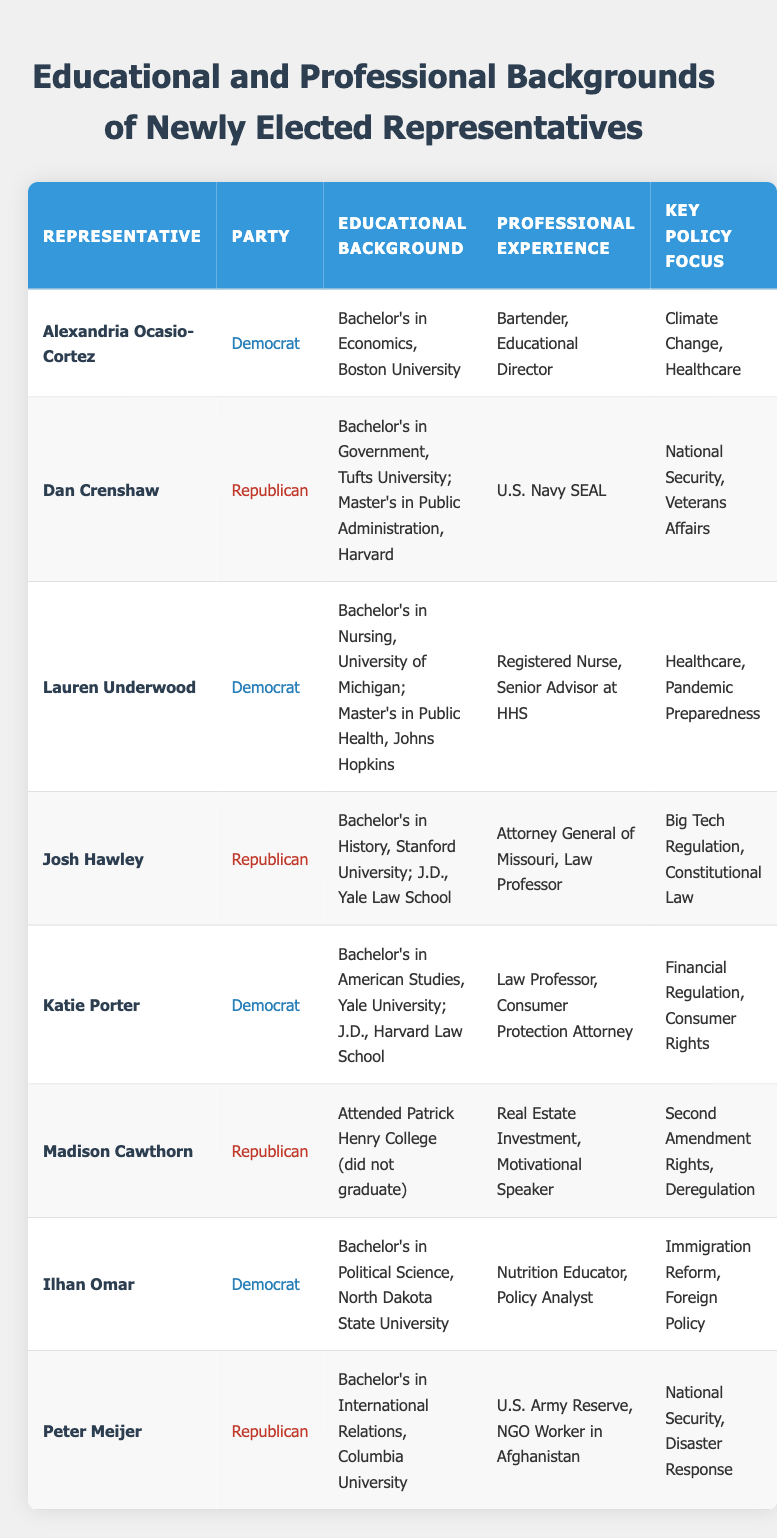What is the educational background of Alexandria Ocasio-Cortez? Alexandria Ocasio-Cortez has a Bachelor's degree in Economics from Boston University, as clearly stated in the "Educational Background" column for her row.
Answer: Bachelor's in Economics, Boston University Which party does Lauren Underwood belong to? In the row for Lauren Underwood, the "Party" column specifies that she is a Democrat.
Answer: Democrat Who has the most extensive educational qualifications? To determine this, we look at the educational background of each representative. Dan Crenshaw has both a Bachelor's in Government and a Master's in Public Administration, whereas others have fewer degrees. Therefore, he has the most extensive qualifications.
Answer: Dan Crenshaw How many representatives have a background in healthcare? We filter the table for representatives whose professional experience or policy focus indicates a healthcare background. Both Alexandria Ocasio-Cortez and Lauren Underwood are directly involved with healthcare. This totals to two representatives with a focus in this area.
Answer: 2 True or False: Madison Cawthorn graduated from Patrick Henry College. The educational background for Madison Cawthorn states that he "Attended Patrick Henry College (did not graduate)," which clearly indicates that he did not complete his degree.
Answer: False What is the average number of educational degrees held by the representatives listed? Counting the degrees: Ocasio-Cortez (1), Crenshaw (2), Underwood (2), Hawley (2), Porter (2), Cawthorn (0), Omar (1), Meijer (1) gives a total of 11 degrees. Since there are 8 representatives, the average is calculated as 11/8 = 1.375 degrees.
Answer: 1.375 Which representative's professional experience includes military service? Peter Meijer is noted to have served in the U.S. Army Reserve, as indicated in the "Professional Experience" column for his row.
Answer: Peter Meijer Which key policy focus is unique to Josh Hawley? Upon examining the key policy focus column, "Big Tech Regulation" is uniquely stated for Josh Hawley, while it is not mentioned for any other representatives.
Answer: Big Tech Regulation How many representatives attended Ivy League schools? The table mentions that Josh Hawley (Yale), Katie Porter (Harvard), and Dan Crenshaw (Harvard) attended Ivy League institutions. There are three distinct representatives who meet this criterion.
Answer: 3 